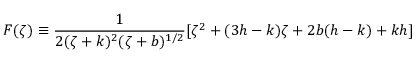Convert formula to latex. <formula><loc_0><loc_0><loc_500><loc_500>F ( \zeta ) \equiv \frac { 1 } { 2 ( \zeta + k ) ^ { 2 } ( \zeta + b ) ^ { 1 / 2 } } [ \zeta ^ { 2 } + ( 3 h - k ) \zeta + 2 b ( h - k ) + k h ]</formula> 